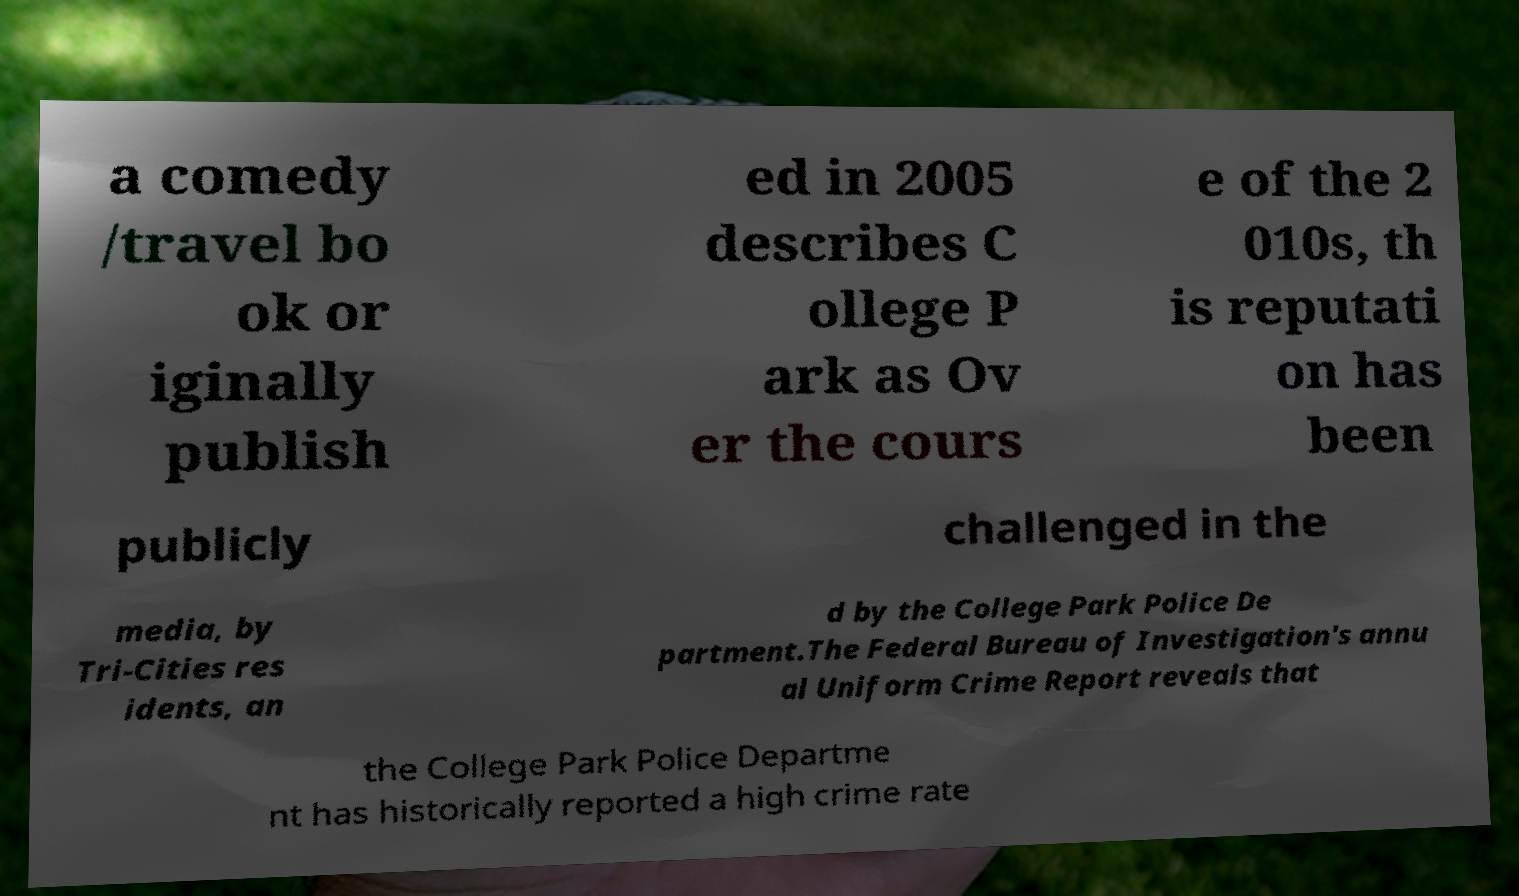Please read and relay the text visible in this image. What does it say? a comedy /travel bo ok or iginally publish ed in 2005 describes C ollege P ark as Ov er the cours e of the 2 010s, th is reputati on has been publicly challenged in the media, by Tri-Cities res idents, an d by the College Park Police De partment.The Federal Bureau of Investigation's annu al Uniform Crime Report reveals that the College Park Police Departme nt has historically reported a high crime rate 